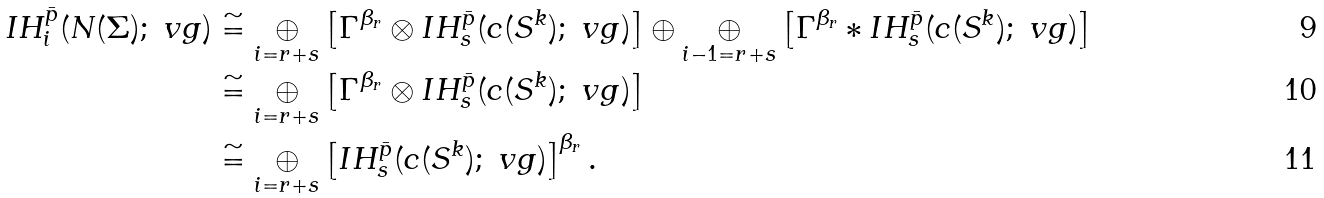Convert formula to latex. <formula><loc_0><loc_0><loc_500><loc_500>I H _ { i } ^ { \bar { p } } ( N ( \Sigma ) ; \ v g ) & \cong \underset { i = r + s } { \oplus } \left [ \Gamma ^ { \beta _ { r } } \otimes I H _ { s } ^ { \bar { p } } ( c ( S ^ { k } ) ; \ v g ) \right ] \oplus \underset { i - 1 = r + s } { \oplus } \left [ \Gamma ^ { \beta _ { r } } * I H _ { s } ^ { \bar { p } } ( c ( S ^ { k } ) ; \ v g ) \right ] \\ & \cong \underset { i = r + s } { \oplus } \left [ \Gamma ^ { \beta _ { r } } \otimes I H _ { s } ^ { \bar { p } } ( c ( S ^ { k } ) ; \ v g ) \right ] \\ & \cong \underset { i = r + s } { \oplus } \left [ I H _ { s } ^ { \bar { p } } ( c ( S ^ { k } ) ; \ v g ) \right ] ^ { \beta _ { r } } .</formula> 